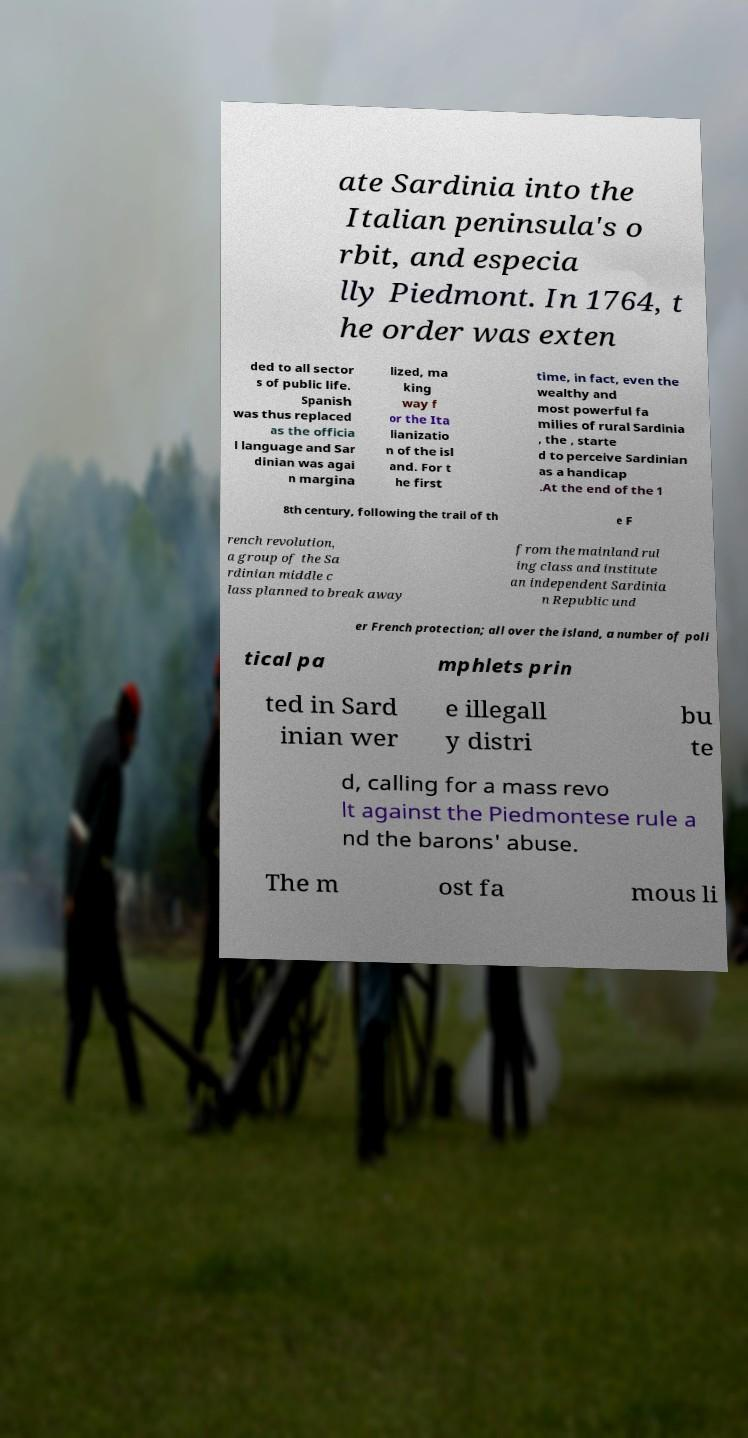There's text embedded in this image that I need extracted. Can you transcribe it verbatim? ate Sardinia into the Italian peninsula's o rbit, and especia lly Piedmont. In 1764, t he order was exten ded to all sector s of public life. Spanish was thus replaced as the officia l language and Sar dinian was agai n margina lized, ma king way f or the Ita lianizatio n of the isl and. For t he first time, in fact, even the wealthy and most powerful fa milies of rural Sardinia , the , starte d to perceive Sardinian as a handicap .At the end of the 1 8th century, following the trail of th e F rench revolution, a group of the Sa rdinian middle c lass planned to break away from the mainland rul ing class and institute an independent Sardinia n Republic und er French protection; all over the island, a number of poli tical pa mphlets prin ted in Sard inian wer e illegall y distri bu te d, calling for a mass revo lt against the Piedmontese rule a nd the barons' abuse. The m ost fa mous li 